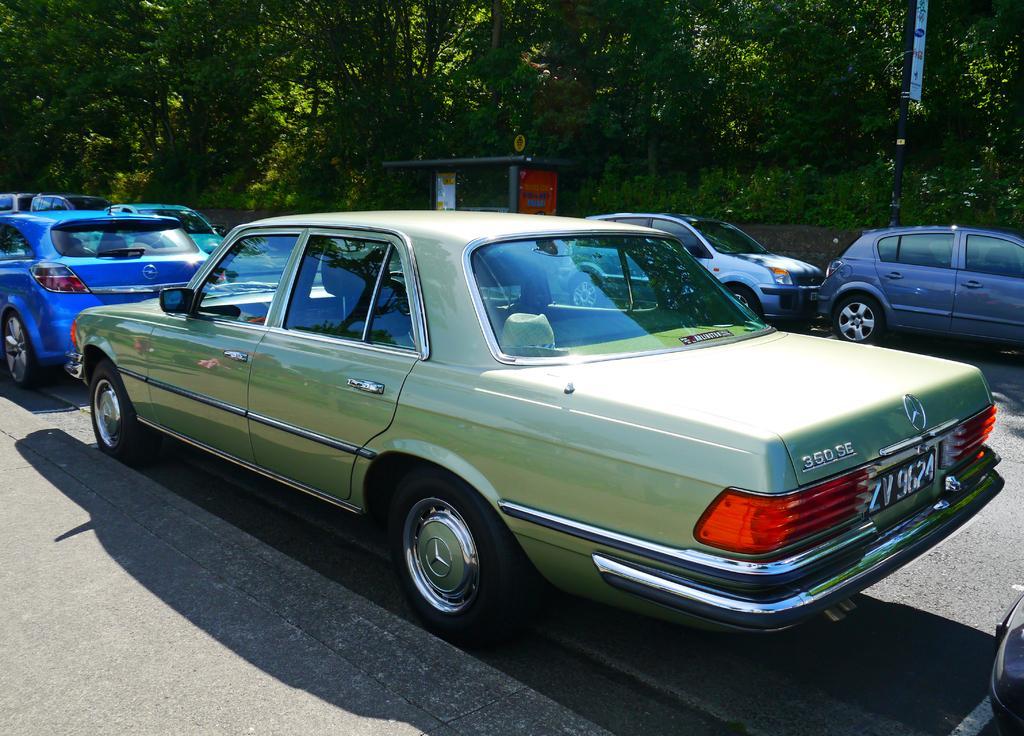Please provide a concise description of this image. In this image there are trees, there is a pole, there is an object on the pole, there are cars on the road, there are cars truncated towards the right of the image, there are cars truncated towards the left of the image, there is an object on the ground. 